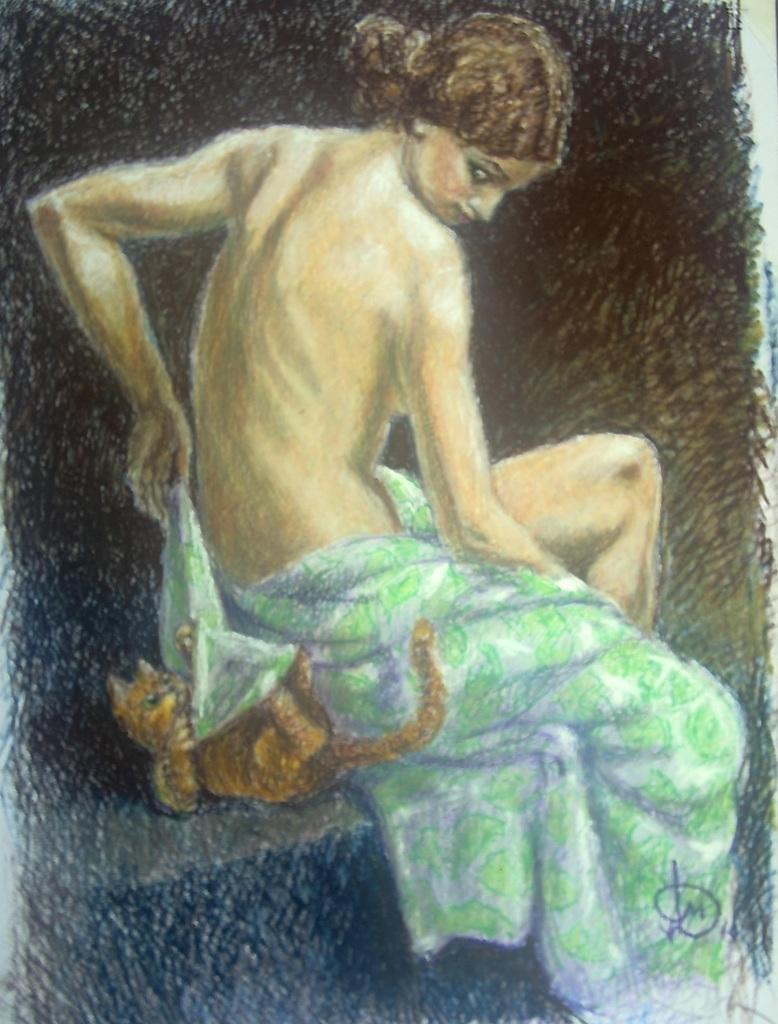In one or two sentences, can you explain what this image depicts? In this image we can see a painting. In the center there is a lady and we can see a cat. 